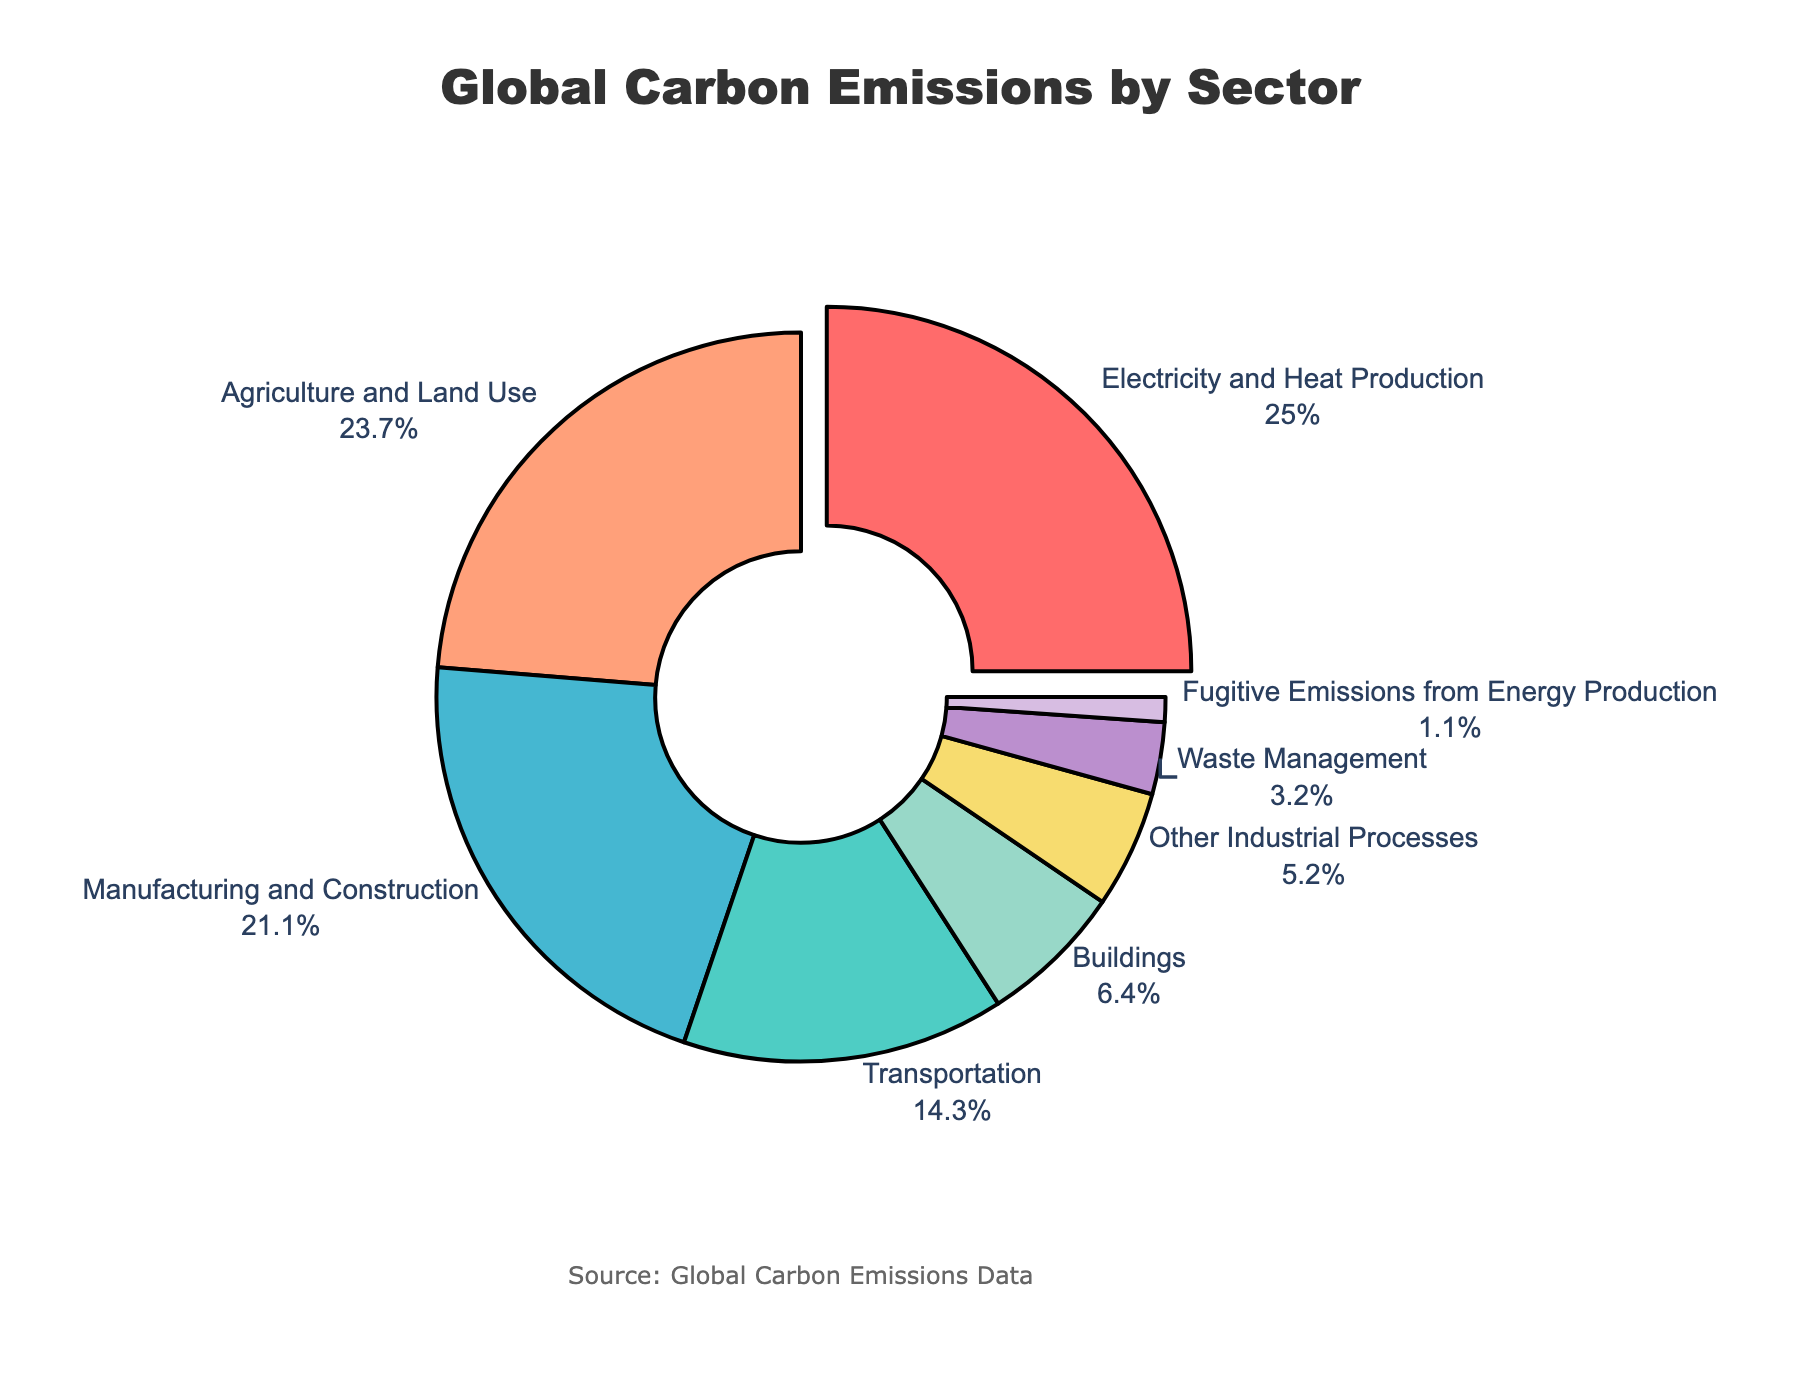Which sector contributes the most to global carbon emissions? By looking at the pie chart, the sector with the largest slice, or the most extended portion, is "Electricity and Heat Production" with a highlighted pull-out.
Answer: Electricity and Heat Production Which sector contributes the least to global carbon emissions? The smallest slice of the pie chart, which has the smallest area, is for "Fugitive Emissions from Energy Production".
Answer: Fugitive Emissions from Energy Production How much more do 'Electricity and Heat Production' and 'Agriculture and Land Use' together contribute to global carbon emissions compared to 'Transportation' and 'Buildings' together? First, we add the contributions of 'Electricity and Heat Production' (25.0%) and 'Agriculture and Land Use' (23.7%). Second, we add the contributions of 'Transportation' (14.3%) and 'Buildings' (6.4%). Finally, we find the difference. (25.0 + 23.7) - (14.3 + 6.4) = 48.7 - 20.7 = 28.0%
Answer: 28.0% Which two sectors combined make up approximately half of the global carbon emissions? We need to identify the two largest slices. Adding 'Electricity and Heat Production' (25.0%) and 'Agriculture and Land Use' (23.7%) together gives 48.7%, which is close to half of the pie chart.
Answer: Electricity and Heat Production and Agriculture and Land Use What is the percentage difference between 'Manufacturing and Construction' and 'Waste Management'? Subtract the percentage of 'Waste Management' (3.2%) from 'Manufacturing and Construction' (21.1%). 21.1 - 3.2 = 17.9%
Answer: 17.9% Which three sectors contribute nearly all together to 50% of the global carbon emissions and also have the closest combined percentage to 50%? To reach nearly 50%, we can combine 'Electricity and Heat Production' (25.0%), 'Transportation' (14.3%), and 'Buildings' (6.4%). 25.0 + 14.3 + 6.4 = 45.7%, which is closest to 50%.
Answer: Electricity and Heat Production, Transportation, and Buildings Between 'Other Industrial Processes' and 'Waste Management', which sector contributes more and by how much? 'Other Industrial Processes' have a larger slice (5.2%) compared to 'Waste Management' (3.2%). To find the difference: 5.2 - 3.2 = 2.0%.
Answer: Other Industrial Processes by 2.0% What fraction of global carbon emissions is contributed by 'Electricity and Heat Production' and 'Manufacturing and Construction' together? Adding the percentages of 'Electricity and Heat Production' (25.0%) and 'Manufacturing and Construction' (21.1%) gives 46.1%. To convert this to a fraction, 46.1% = 46.1/100 = 461/1000 = 461/1000
Answer: 461/1000 or 46.1% In terms of visual size, what can be said about the contribution of 'Buildings' compared to 'Other Industrial Processes'? The sector 'Buildings' has a larger visual size (6.4%) than 'Other Industrial Processes' (5.2%), indicating that it has a slightly larger contribution.
Answer: Buildings contributes more 